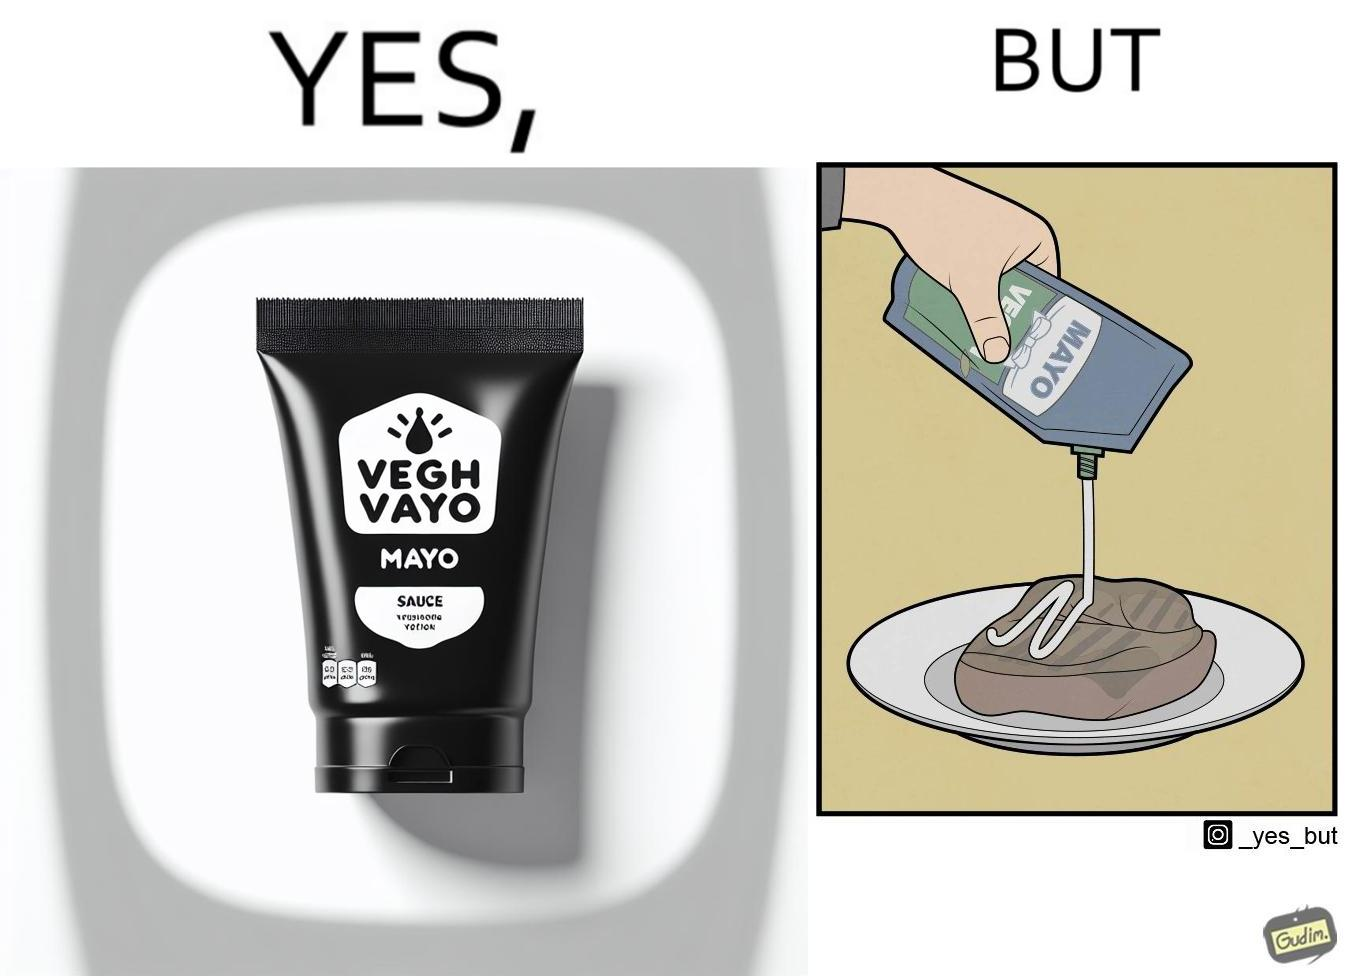Describe the contrast between the left and right parts of this image. In the left part of the image: a vegan mayo sauce packet In the right part of the image: pouring vegan mayo sauce from a packet on a rib steak 